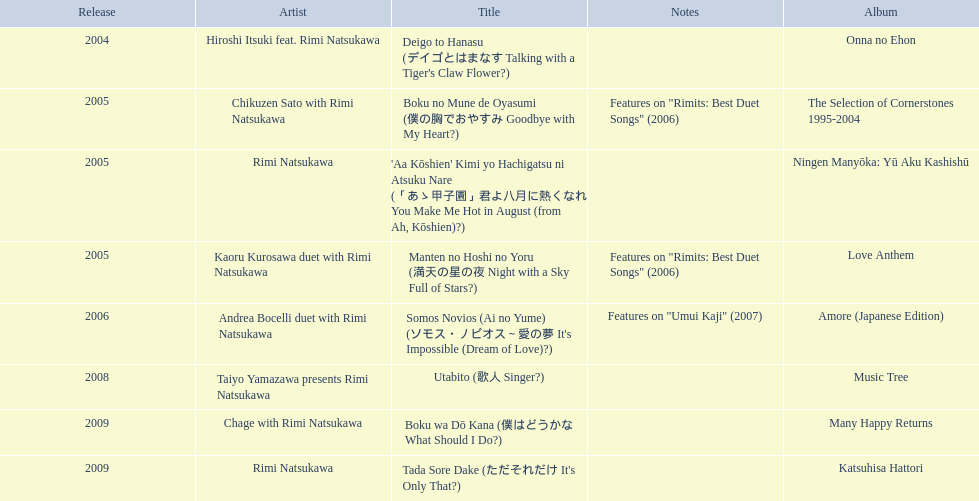Which rimi natsukawa album title was launched in 2004? Deigo to Hanasu (デイゴとはまなす Talking with a Tiger's Claw Flower?). Which title has notes featured in/on "rimits: best duet songs" 2006? Manten no Hoshi no Yoru (満天の星の夜 Night with a Sky Full of Stars?). Which title has the same notes as a night with a sky full of stars? Boku no Mune de Oyasumi (僕の胸でおやすみ Goodbye with My Heart?). 